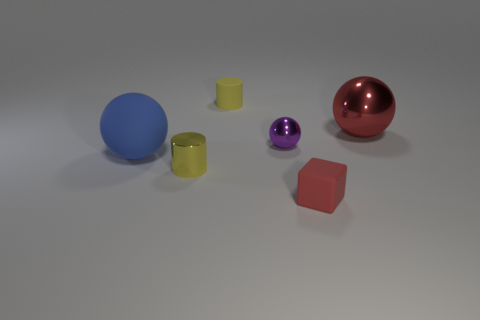The metal ball that is the same color as the small cube is what size?
Ensure brevity in your answer.  Large. The tiny object that is the same color as the small metal cylinder is what shape?
Make the answer very short. Cylinder. There is a small red thing that is made of the same material as the big blue ball; what is its shape?
Ensure brevity in your answer.  Cube. Is there anything else that is the same color as the tiny metallic ball?
Your answer should be very brief. No. Does the rubber block have the same color as the large object that is to the right of the purple metallic object?
Keep it short and to the point. Yes. Are there fewer cylinders behind the tiny yellow matte cylinder than large cyan rubber blocks?
Make the answer very short. No. What is the material of the large thing to the left of the small red rubber object?
Provide a short and direct response. Rubber. How many other objects are the same size as the purple metal ball?
Your response must be concise. 3. There is a yellow metallic cylinder; is it the same size as the red thing in front of the tiny shiny cylinder?
Provide a succinct answer. Yes. What shape is the large object left of the tiny yellow object that is to the left of the small cylinder behind the large red object?
Offer a very short reply. Sphere. 